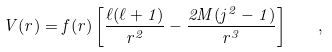Convert formula to latex. <formula><loc_0><loc_0><loc_500><loc_500>V ( r ) = f ( r ) \left [ \frac { \ell ( \ell + 1 ) } { r ^ { 2 } } - \frac { 2 M ( j ^ { 2 } - 1 ) } { r ^ { 3 } } \right ] \quad ,</formula> 